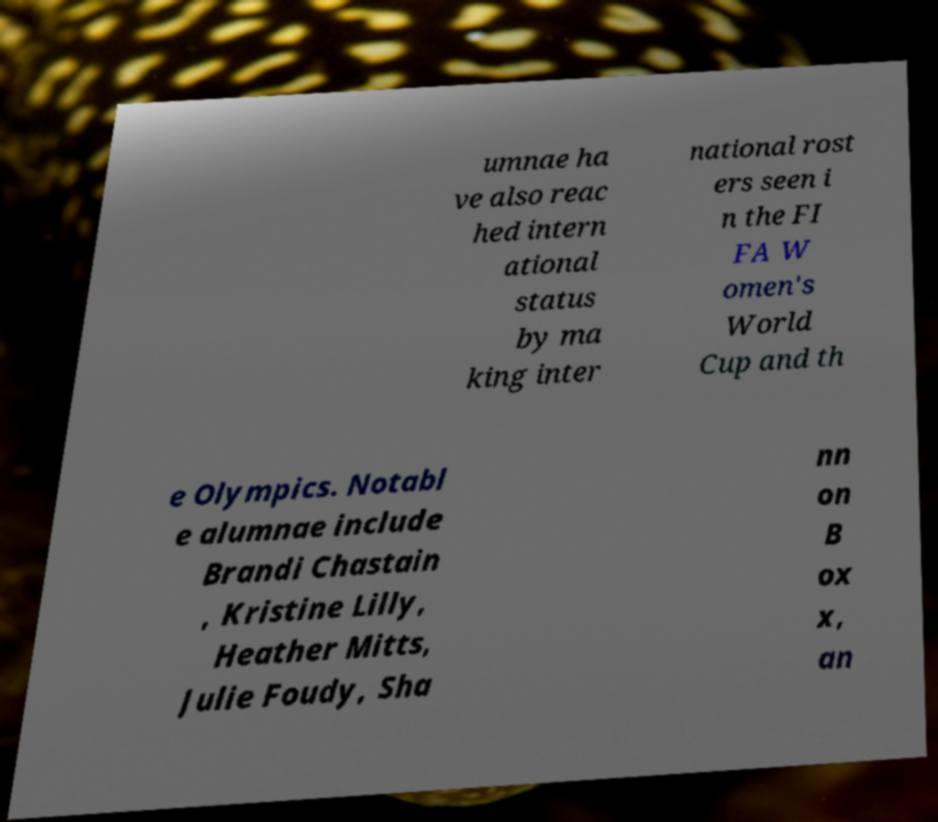I need the written content from this picture converted into text. Can you do that? umnae ha ve also reac hed intern ational status by ma king inter national rost ers seen i n the FI FA W omen's World Cup and th e Olympics. Notabl e alumnae include Brandi Chastain , Kristine Lilly, Heather Mitts, Julie Foudy, Sha nn on B ox x, an 